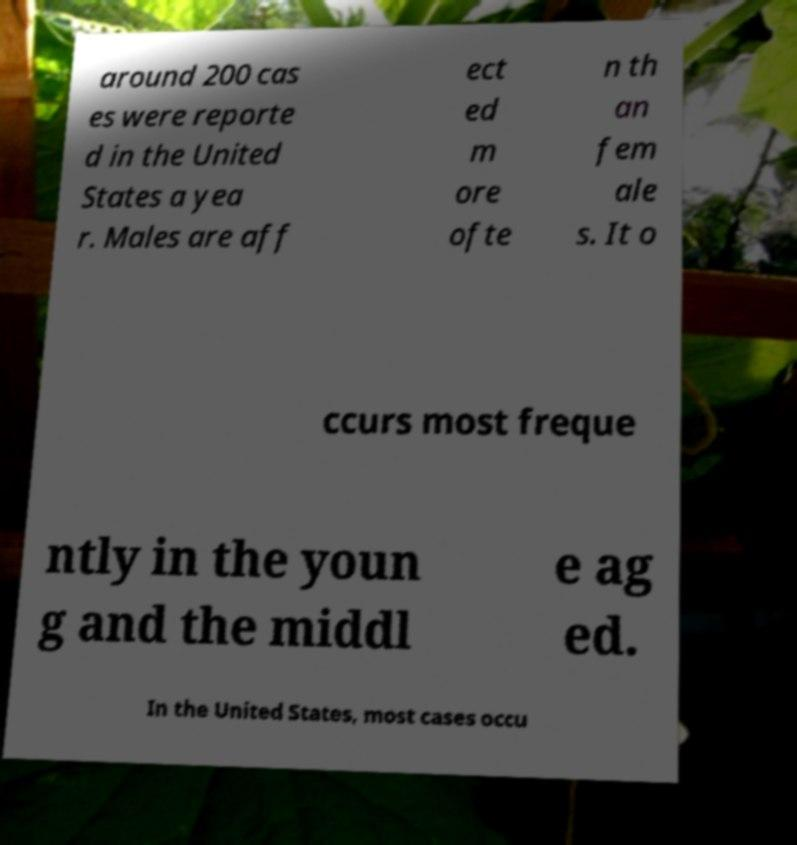Please identify and transcribe the text found in this image. around 200 cas es were reporte d in the United States a yea r. Males are aff ect ed m ore ofte n th an fem ale s. It o ccurs most freque ntly in the youn g and the middl e ag ed. In the United States, most cases occu 